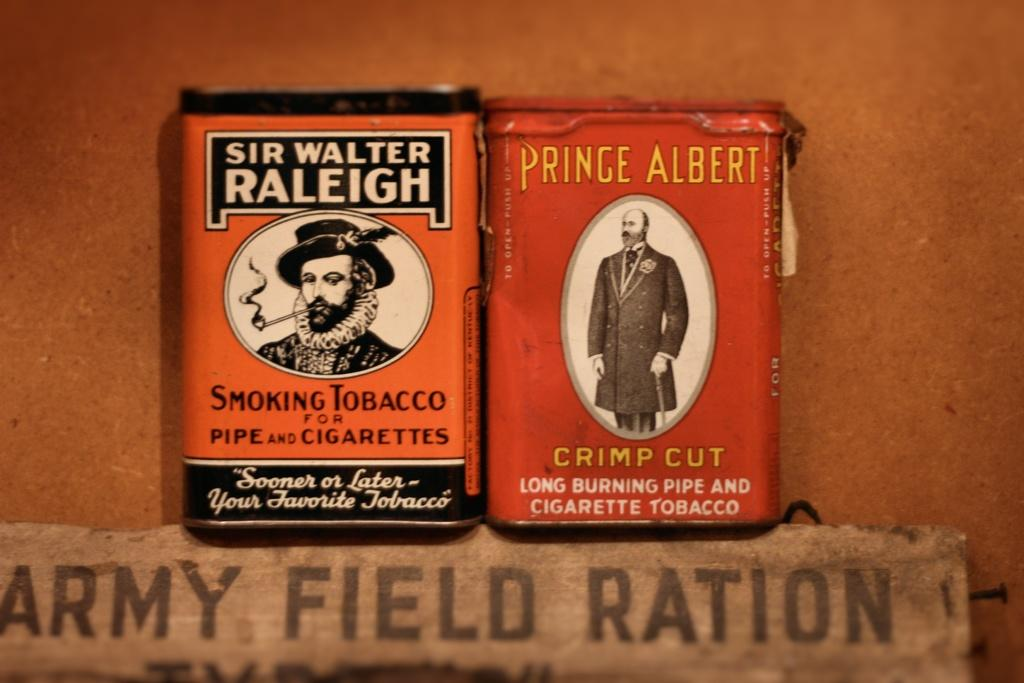<image>
Render a clear and concise summary of the photo. Two boxes next to one another with one that says Prince Albert on it. 